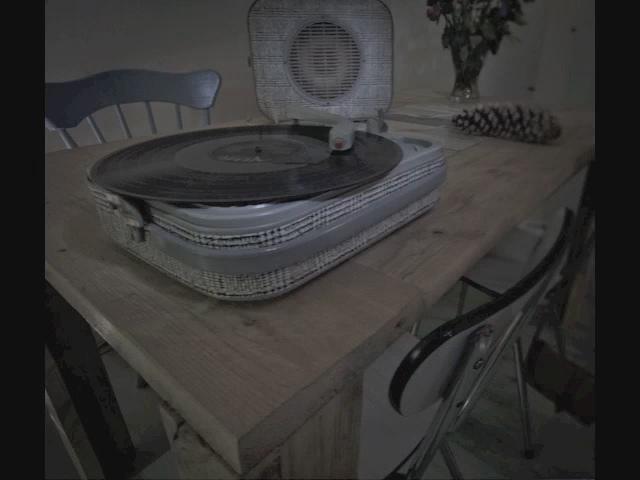How many cups are in the photo?
Give a very brief answer. 0. How many chairs are there?
Give a very brief answer. 2. How many airplanes are in front of the control towers?
Give a very brief answer. 0. 